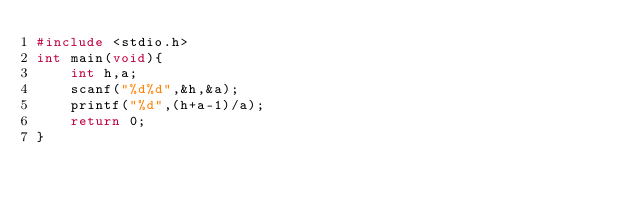<code> <loc_0><loc_0><loc_500><loc_500><_C_>#include <stdio.h>
int main(void){
    int h,a;
    scanf("%d%d",&h,&a);
    printf("%d",(h+a-1)/a);
    return 0;
}</code> 